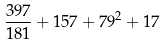Convert formula to latex. <formula><loc_0><loc_0><loc_500><loc_500>\frac { 3 9 7 } { 1 8 1 } + 1 5 7 + 7 9 ^ { 2 } + 1 7</formula> 